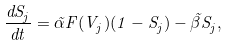<formula> <loc_0><loc_0><loc_500><loc_500>\frac { d S _ { j } } { d t } = \tilde { \alpha } F ( V _ { j } ) ( 1 - S _ { j } ) - \tilde { \beta } S _ { j } ,</formula> 